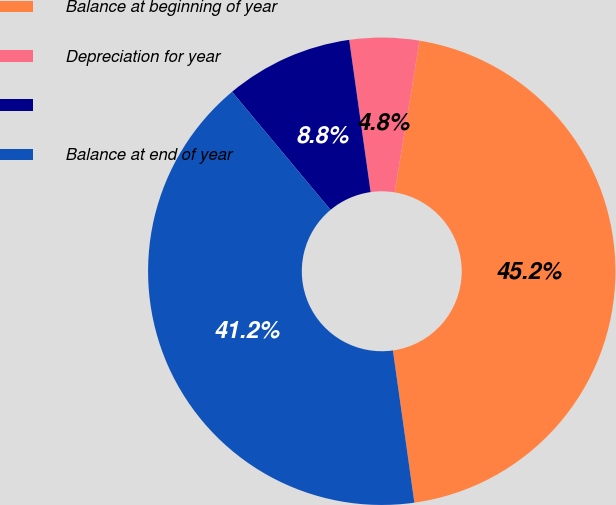<chart> <loc_0><loc_0><loc_500><loc_500><pie_chart><fcel>Balance at beginning of year<fcel>Depreciation for year<fcel>Unnamed: 2<fcel>Balance at end of year<nl><fcel>45.19%<fcel>4.81%<fcel>8.84%<fcel>41.16%<nl></chart> 